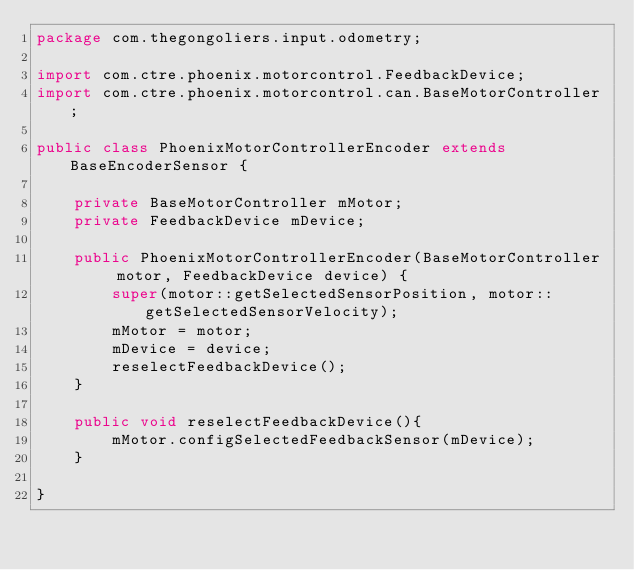<code> <loc_0><loc_0><loc_500><loc_500><_Java_>package com.thegongoliers.input.odometry;

import com.ctre.phoenix.motorcontrol.FeedbackDevice;
import com.ctre.phoenix.motorcontrol.can.BaseMotorController;

public class PhoenixMotorControllerEncoder extends BaseEncoderSensor {

    private BaseMotorController mMotor;
    private FeedbackDevice mDevice;

    public PhoenixMotorControllerEncoder(BaseMotorController motor, FeedbackDevice device) {
        super(motor::getSelectedSensorPosition, motor::getSelectedSensorVelocity);
        mMotor = motor;
        mDevice = device;
        reselectFeedbackDevice();
    }

    public void reselectFeedbackDevice(){
        mMotor.configSelectedFeedbackSensor(mDevice);
    }

}</code> 